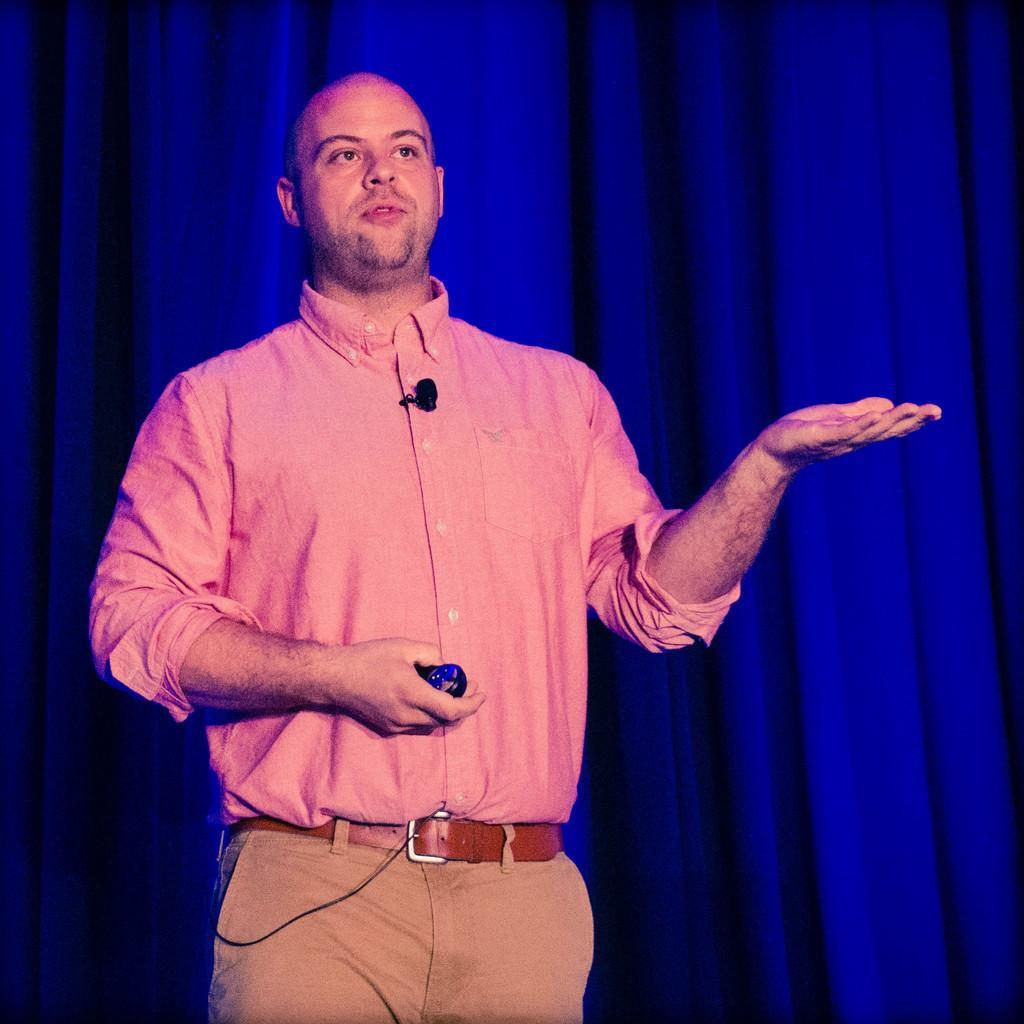What is the man in the image doing? The man is standing in the image with a microphone and a remote in his hand. What object does the man have that is used for amplifying sound? The man has a microphone in the image. What object does the man have that is used for controlling electronic devices? The man is holding a remote in his hand. What color is the curtain in the background of the image? The curtain in the background of the image is blue. Can you see a horse in the image? No, there is no horse present in the image. 